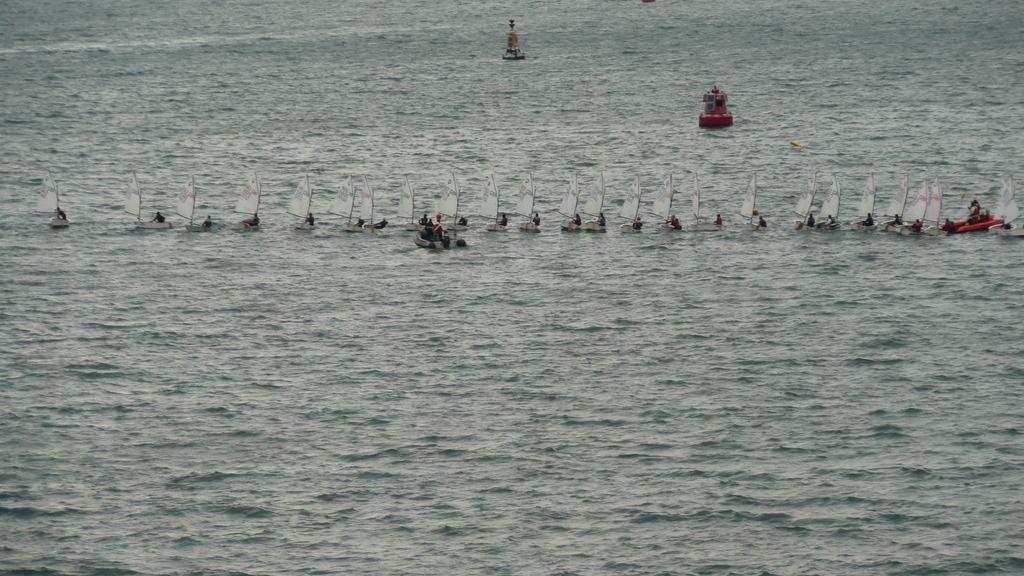Please provide a concise description of this image. In this image, we can see few people are sailing a boat on the water. 